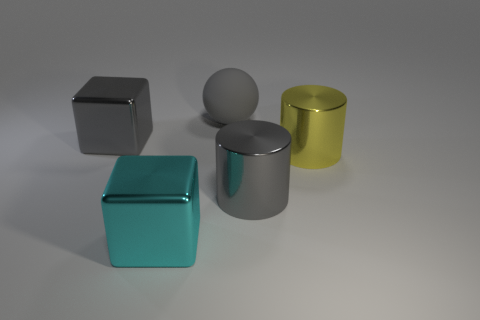Subtract 2 cubes. How many cubes are left? 0 Subtract all gray cylinders. How many cylinders are left? 1 Add 1 rubber things. How many objects exist? 6 Add 4 gray metallic cylinders. How many gray metallic cylinders are left? 5 Add 5 small spheres. How many small spheres exist? 5 Subtract 0 red cylinders. How many objects are left? 5 Subtract all balls. How many objects are left? 4 Subtract all blue spheres. Subtract all blue cylinders. How many spheres are left? 1 Subtract all blue blocks. How many gray cylinders are left? 1 Subtract all large metal cylinders. Subtract all large yellow metal cylinders. How many objects are left? 2 